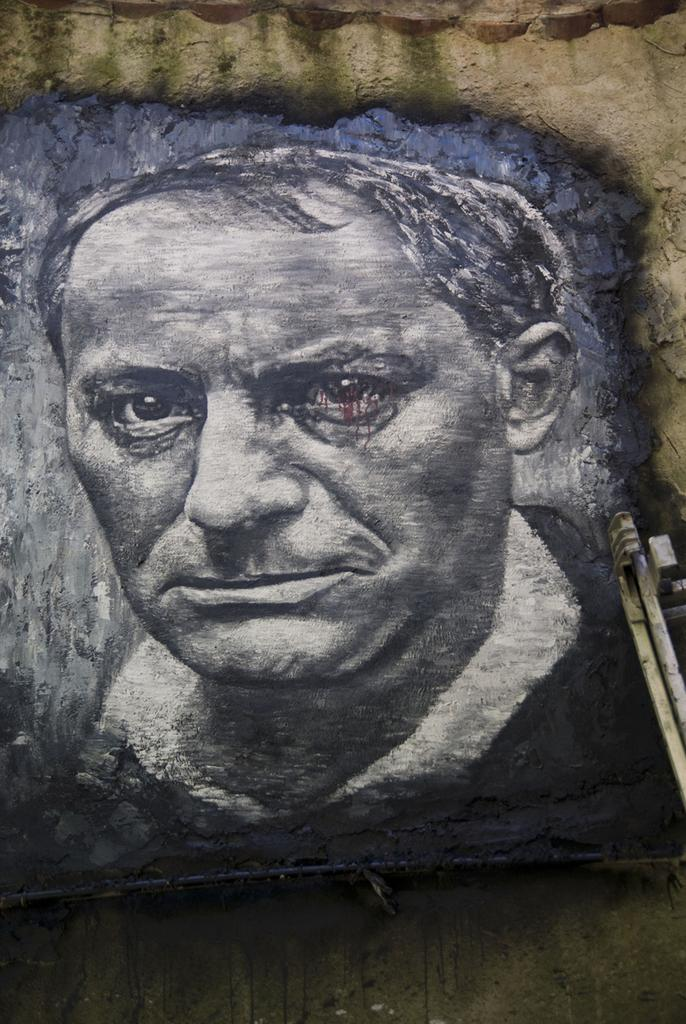What is the main subject of the image? There is a painting in the image. What does the painting depict? The painting depicts a man. Where is the painting located? The painting is on a surface. Can you tell me how many basketballs are in the painting? There is no basketball present in the painting; it depicts a man. Is the man swimming in the painting? There is no indication of swimming in the painting; it simply depicts a man. 